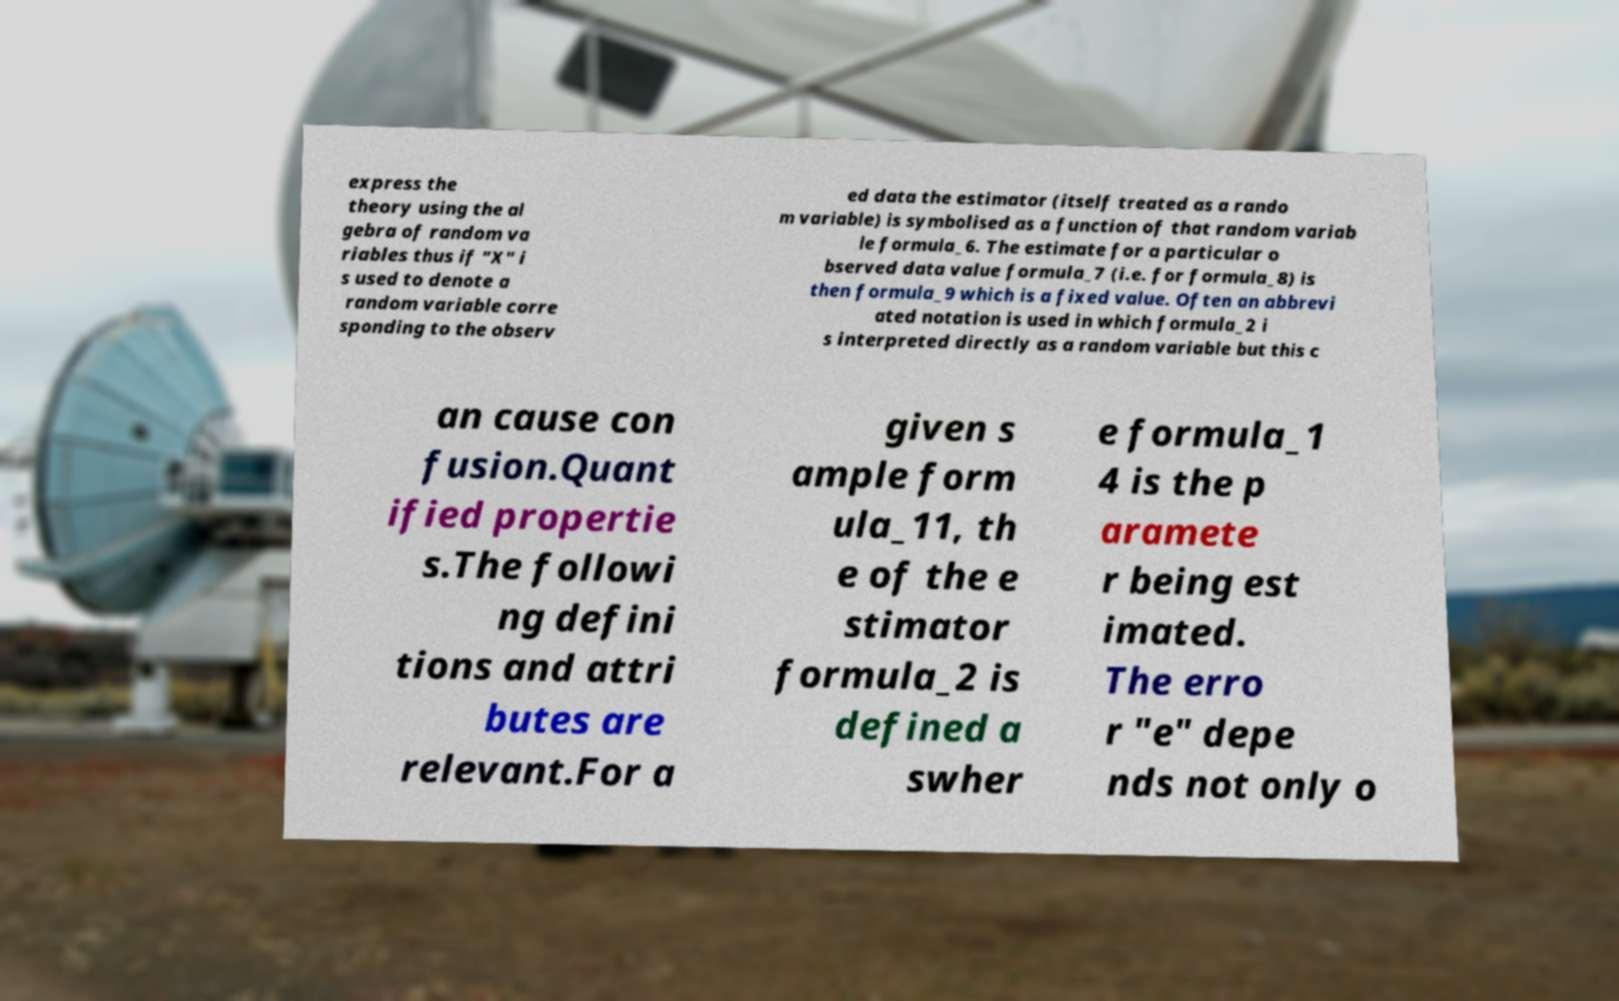Please identify and transcribe the text found in this image. express the theory using the al gebra of random va riables thus if "X" i s used to denote a random variable corre sponding to the observ ed data the estimator (itself treated as a rando m variable) is symbolised as a function of that random variab le formula_6. The estimate for a particular o bserved data value formula_7 (i.e. for formula_8) is then formula_9 which is a fixed value. Often an abbrevi ated notation is used in which formula_2 i s interpreted directly as a random variable but this c an cause con fusion.Quant ified propertie s.The followi ng defini tions and attri butes are relevant.For a given s ample form ula_11, th e of the e stimator formula_2 is defined a swher e formula_1 4 is the p aramete r being est imated. The erro r "e" depe nds not only o 